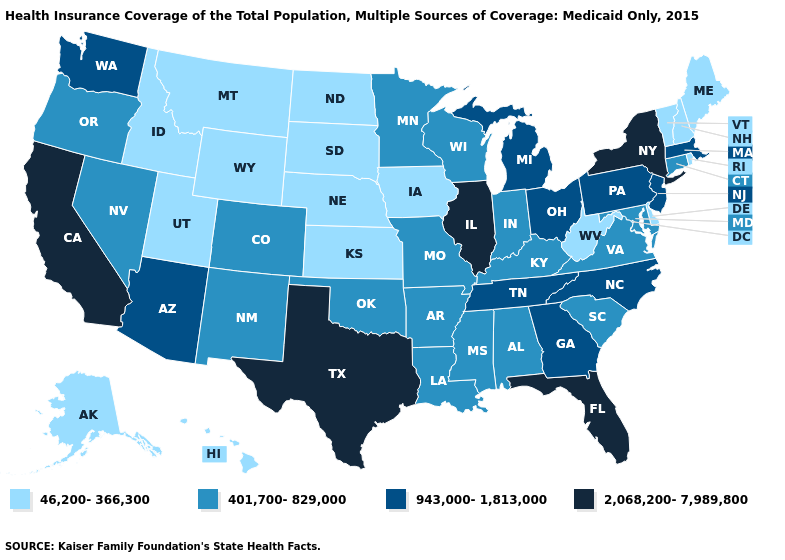Name the states that have a value in the range 401,700-829,000?
Give a very brief answer. Alabama, Arkansas, Colorado, Connecticut, Indiana, Kentucky, Louisiana, Maryland, Minnesota, Mississippi, Missouri, Nevada, New Mexico, Oklahoma, Oregon, South Carolina, Virginia, Wisconsin. How many symbols are there in the legend?
Concise answer only. 4. Does Nevada have the lowest value in the USA?
Give a very brief answer. No. What is the lowest value in the Northeast?
Give a very brief answer. 46,200-366,300. What is the value of Nevada?
Concise answer only. 401,700-829,000. Does Alaska have the highest value in the USA?
Short answer required. No. What is the lowest value in the USA?
Write a very short answer. 46,200-366,300. What is the value of West Virginia?
Keep it brief. 46,200-366,300. Is the legend a continuous bar?
Concise answer only. No. What is the lowest value in the MidWest?
Concise answer only. 46,200-366,300. Name the states that have a value in the range 2,068,200-7,989,800?
Answer briefly. California, Florida, Illinois, New York, Texas. Name the states that have a value in the range 46,200-366,300?
Give a very brief answer. Alaska, Delaware, Hawaii, Idaho, Iowa, Kansas, Maine, Montana, Nebraska, New Hampshire, North Dakota, Rhode Island, South Dakota, Utah, Vermont, West Virginia, Wyoming. What is the highest value in the USA?
Quick response, please. 2,068,200-7,989,800. What is the value of Connecticut?
Quick response, please. 401,700-829,000. 